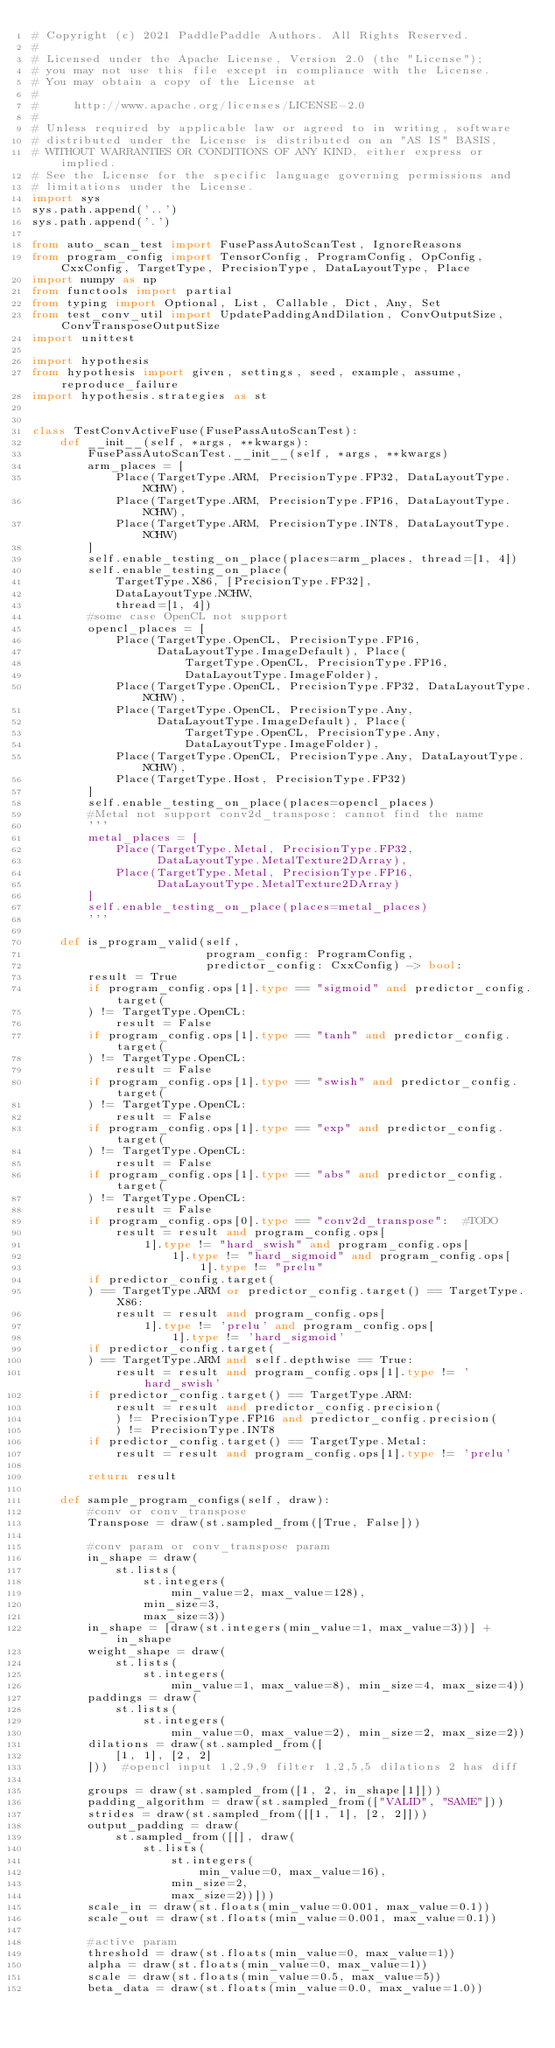Convert code to text. <code><loc_0><loc_0><loc_500><loc_500><_Python_># Copyright (c) 2021 PaddlePaddle Authors. All Rights Reserved.
#
# Licensed under the Apache License, Version 2.0 (the "License");
# you may not use this file except in compliance with the License.
# You may obtain a copy of the License at
#
#     http://www.apache.org/licenses/LICENSE-2.0
#
# Unless required by applicable law or agreed to in writing, software
# distributed under the License is distributed on an "AS IS" BASIS,
# WITHOUT WARRANTIES OR CONDITIONS OF ANY KIND, either express or implied.
# See the License for the specific language governing permissions and
# limitations under the License.
import sys
sys.path.append('..')
sys.path.append('.')

from auto_scan_test import FusePassAutoScanTest, IgnoreReasons
from program_config import TensorConfig, ProgramConfig, OpConfig, CxxConfig, TargetType, PrecisionType, DataLayoutType, Place
import numpy as np
from functools import partial
from typing import Optional, List, Callable, Dict, Any, Set
from test_conv_util import UpdatePaddingAndDilation, ConvOutputSize, ConvTransposeOutputSize
import unittest

import hypothesis
from hypothesis import given, settings, seed, example, assume, reproduce_failure
import hypothesis.strategies as st


class TestConvActiveFuse(FusePassAutoScanTest):
    def __init__(self, *args, **kwargs):
        FusePassAutoScanTest.__init__(self, *args, **kwargs)
        arm_places = [
            Place(TargetType.ARM, PrecisionType.FP32, DataLayoutType.NCHW),
            Place(TargetType.ARM, PrecisionType.FP16, DataLayoutType.NCHW),
            Place(TargetType.ARM, PrecisionType.INT8, DataLayoutType.NCHW)
        ]
        self.enable_testing_on_place(places=arm_places, thread=[1, 4])
        self.enable_testing_on_place(
            TargetType.X86, [PrecisionType.FP32],
            DataLayoutType.NCHW,
            thread=[1, 4])
        #some case OpenCL not support
        opencl_places = [
            Place(TargetType.OpenCL, PrecisionType.FP16,
                  DataLayoutType.ImageDefault), Place(
                      TargetType.OpenCL, PrecisionType.FP16,
                      DataLayoutType.ImageFolder),
            Place(TargetType.OpenCL, PrecisionType.FP32, DataLayoutType.NCHW),
            Place(TargetType.OpenCL, PrecisionType.Any,
                  DataLayoutType.ImageDefault), Place(
                      TargetType.OpenCL, PrecisionType.Any,
                      DataLayoutType.ImageFolder),
            Place(TargetType.OpenCL, PrecisionType.Any, DataLayoutType.NCHW),
            Place(TargetType.Host, PrecisionType.FP32)
        ]
        self.enable_testing_on_place(places=opencl_places)
        #Metal not support conv2d_transpose: cannot find the name
        '''       
        metal_places = [
            Place(TargetType.Metal, PrecisionType.FP32,
                  DataLayoutType.MetalTexture2DArray),
            Place(TargetType.Metal, PrecisionType.FP16,
                  DataLayoutType.MetalTexture2DArray)
        ]
        self.enable_testing_on_place(places=metal_places)
        '''

    def is_program_valid(self,
                         program_config: ProgramConfig,
                         predictor_config: CxxConfig) -> bool:
        result = True
        if program_config.ops[1].type == "sigmoid" and predictor_config.target(
        ) != TargetType.OpenCL:
            result = False
        if program_config.ops[1].type == "tanh" and predictor_config.target(
        ) != TargetType.OpenCL:
            result = False
        if program_config.ops[1].type == "swish" and predictor_config.target(
        ) != TargetType.OpenCL:
            result = False
        if program_config.ops[1].type == "exp" and predictor_config.target(
        ) != TargetType.OpenCL:
            result = False
        if program_config.ops[1].type == "abs" and predictor_config.target(
        ) != TargetType.OpenCL:
            result = False
        if program_config.ops[0].type == "conv2d_transpose":  #TODO
            result = result and program_config.ops[
                1].type != "hard_swish" and program_config.ops[
                    1].type != "hard_sigmoid" and program_config.ops[
                        1].type != "prelu"
        if predictor_config.target(
        ) == TargetType.ARM or predictor_config.target() == TargetType.X86:
            result = result and program_config.ops[
                1].type != 'prelu' and program_config.ops[
                    1].type != 'hard_sigmoid'
        if predictor_config.target(
        ) == TargetType.ARM and self.depthwise == True:
            result = result and program_config.ops[1].type != 'hard_swish'
        if predictor_config.target() == TargetType.ARM:
            result = result and predictor_config.precision(
            ) != PrecisionType.FP16 and predictor_config.precision(
            ) != PrecisionType.INT8
        if predictor_config.target() == TargetType.Metal:
            result = result and program_config.ops[1].type != 'prelu'

        return result

    def sample_program_configs(self, draw):
        #conv or conv_transpose
        Transpose = draw(st.sampled_from([True, False]))

        #conv param or conv_transpose param
        in_shape = draw(
            st.lists(
                st.integers(
                    min_value=2, max_value=128),
                min_size=3,
                max_size=3))
        in_shape = [draw(st.integers(min_value=1, max_value=3))] + in_shape
        weight_shape = draw(
            st.lists(
                st.integers(
                    min_value=1, max_value=8), min_size=4, max_size=4))
        paddings = draw(
            st.lists(
                st.integers(
                    min_value=0, max_value=2), min_size=2, max_size=2))
        dilations = draw(st.sampled_from([
            [1, 1], [2, 2]
        ]))  #opencl input 1,2,9,9 filter 1,2,5,5 dilations 2 has diff

        groups = draw(st.sampled_from([1, 2, in_shape[1]]))
        padding_algorithm = draw(st.sampled_from(["VALID", "SAME"]))
        strides = draw(st.sampled_from([[1, 1], [2, 2]]))
        output_padding = draw(
            st.sampled_from([[], draw(
                st.lists(
                    st.integers(
                        min_value=0, max_value=16),
                    min_size=2,
                    max_size=2))]))
        scale_in = draw(st.floats(min_value=0.001, max_value=0.1))
        scale_out = draw(st.floats(min_value=0.001, max_value=0.1))

        #active param
        threshold = draw(st.floats(min_value=0, max_value=1))
        alpha = draw(st.floats(min_value=0, max_value=1))
        scale = draw(st.floats(min_value=0.5, max_value=5))
        beta_data = draw(st.floats(min_value=0.0, max_value=1.0))</code> 